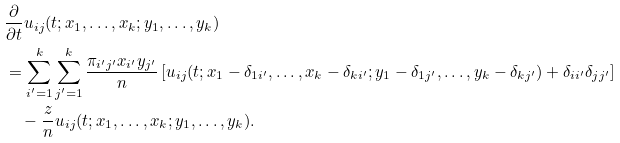<formula> <loc_0><loc_0><loc_500><loc_500>& \frac { \partial } { \partial t } u _ { i j } ( t ; x _ { 1 } , \dots , x _ { k } ; y _ { 1 } , \dots , y _ { k } ) \\ & = \sum _ { i ^ { \prime } = 1 } ^ { k } \sum _ { j ^ { \prime } = 1 } ^ { k } \frac { \pi _ { i ^ { \prime } j ^ { \prime } } x _ { i ^ { \prime } } y _ { j ^ { \prime } } } { n } \left [ u _ { i j } ( t ; x _ { 1 } - \delta _ { 1 i ^ { \prime } } , \dots , x _ { k } - \delta _ { k i ^ { \prime } } ; y _ { 1 } - \delta _ { 1 j ^ { \prime } } , \dots , y _ { k } - \delta _ { k j ^ { \prime } } ) + \delta _ { i i ^ { \prime } } \delta _ { j j ^ { \prime } } \right ] \\ & \quad - \frac { z } { n } u _ { i j } ( t ; x _ { 1 } , \dots , x _ { k } ; y _ { 1 } , \dots , y _ { k } ) .</formula> 